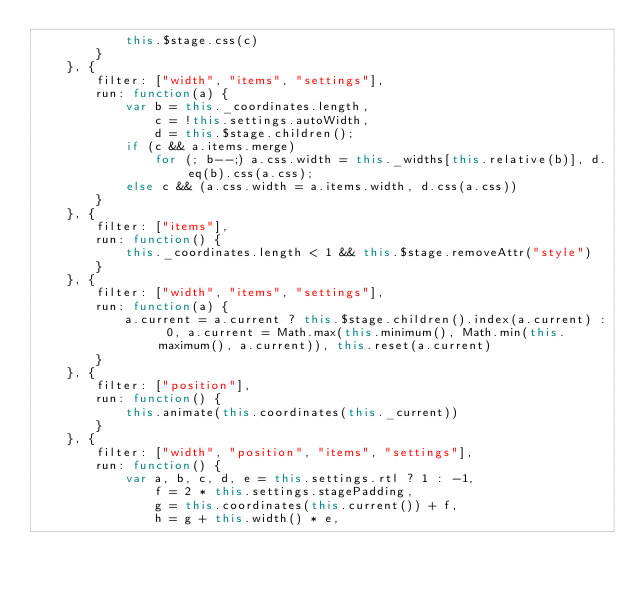Convert code to text. <code><loc_0><loc_0><loc_500><loc_500><_JavaScript_>            this.$stage.css(c)
        }
    }, {
        filter: ["width", "items", "settings"],
        run: function(a) {
            var b = this._coordinates.length,
                c = !this.settings.autoWidth,
                d = this.$stage.children();
            if (c && a.items.merge)
                for (; b--;) a.css.width = this._widths[this.relative(b)], d.eq(b).css(a.css);
            else c && (a.css.width = a.items.width, d.css(a.css))
        }
    }, {
        filter: ["items"],
        run: function() {
            this._coordinates.length < 1 && this.$stage.removeAttr("style")
        }
    }, {
        filter: ["width", "items", "settings"],
        run: function(a) {
            a.current = a.current ? this.$stage.children().index(a.current) : 0, a.current = Math.max(this.minimum(), Math.min(this.maximum(), a.current)), this.reset(a.current)
        }
    }, {
        filter: ["position"],
        run: function() {
            this.animate(this.coordinates(this._current))
        }
    }, {
        filter: ["width", "position", "items", "settings"],
        run: function() {
            var a, b, c, d, e = this.settings.rtl ? 1 : -1,
                f = 2 * this.settings.stagePadding,
                g = this.coordinates(this.current()) + f,
                h = g + this.width() * e,</code> 